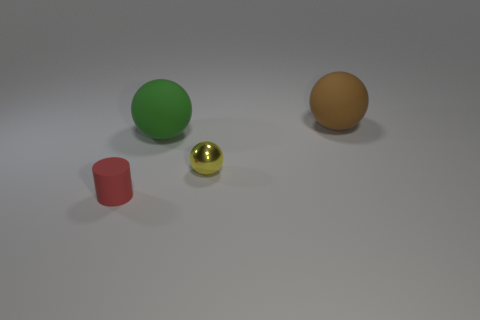Add 2 brown things. How many objects exist? 6 Subtract all rubber balls. How many balls are left? 1 Subtract all yellow spheres. How many spheres are left? 2 Subtract all balls. How many objects are left? 1 Subtract 2 spheres. How many spheres are left? 1 Subtract all red spheres. How many cyan cylinders are left? 0 Subtract all small blue matte balls. Subtract all tiny yellow metallic things. How many objects are left? 3 Add 2 tiny red rubber objects. How many tiny red rubber objects are left? 3 Add 4 red cylinders. How many red cylinders exist? 5 Subtract 0 purple cubes. How many objects are left? 4 